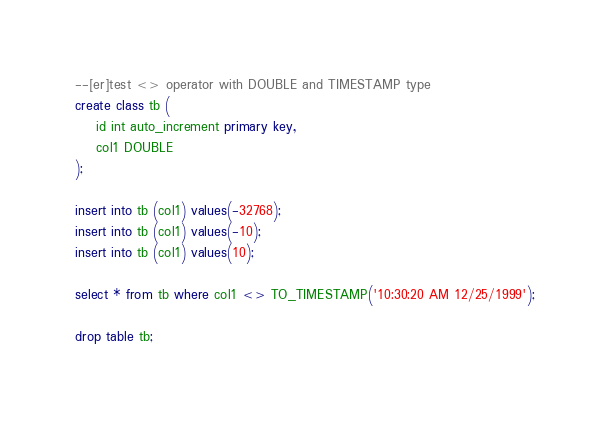<code> <loc_0><loc_0><loc_500><loc_500><_SQL_>--[er]test <> operator with DOUBLE and TIMESTAMP type
create class tb ( 
	id int auto_increment primary key,
	col1 DOUBLE
);

insert into tb (col1) values(-32768);
insert into tb (col1) values(-10);
insert into tb (col1) values(10);

select * from tb where col1 <> TO_TIMESTAMP('10:30:20 AM 12/25/1999');

drop table tb;

</code> 